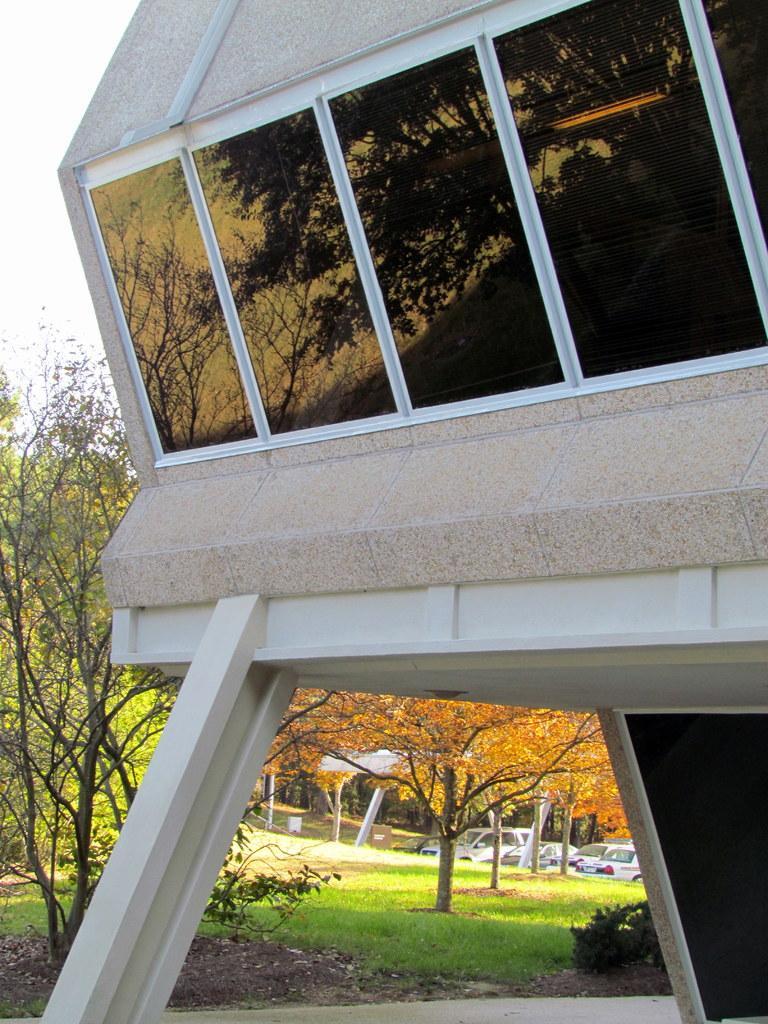Can you describe this image briefly? In this image I can see the building in white and cream color and I can also see few glass windows. Background I can see few trees in green color, few vehicles and the sky is in white color. 